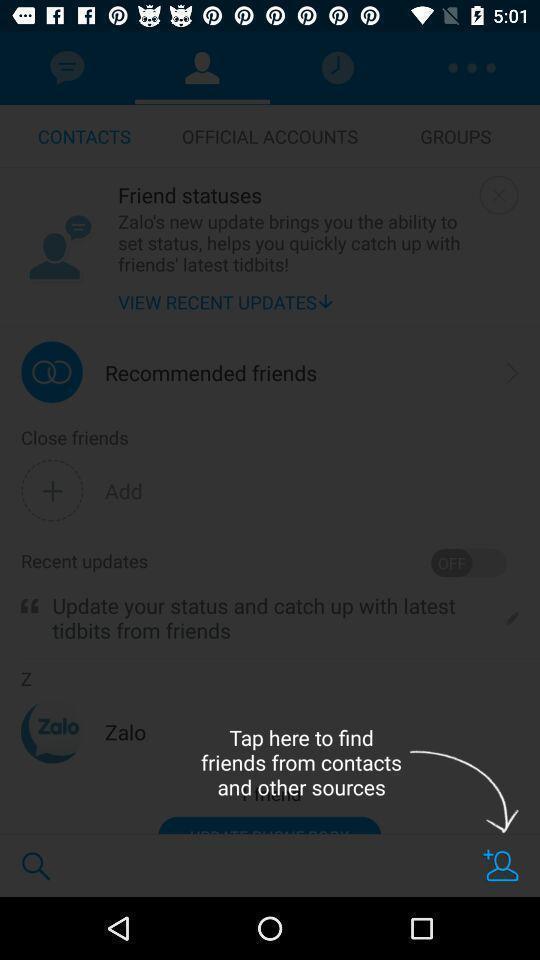Give me a narrative description of this picture. Push up instruction page displaying to find contacts. 